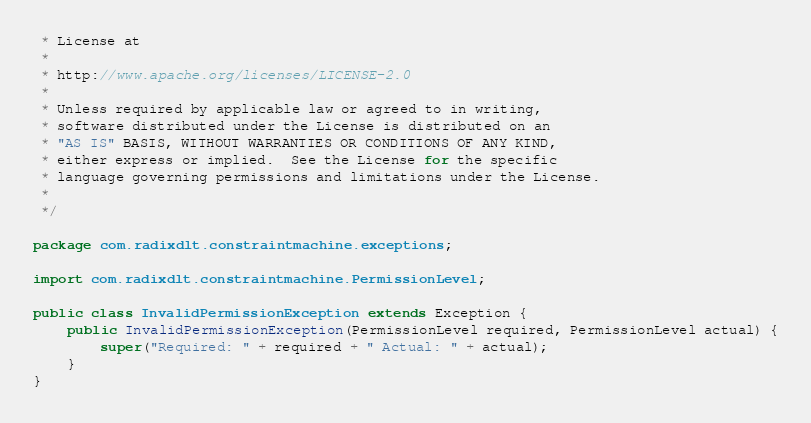Convert code to text. <code><loc_0><loc_0><loc_500><loc_500><_Java_> * License at
 *
 * http://www.apache.org/licenses/LICENSE-2.0
 *
 * Unless required by applicable law or agreed to in writing,
 * software distributed under the License is distributed on an
 * "AS IS" BASIS, WITHOUT WARRANTIES OR CONDITIONS OF ANY KIND,
 * either express or implied.  See the License for the specific
 * language governing permissions and limitations under the License.
 *
 */

package com.radixdlt.constraintmachine.exceptions;

import com.radixdlt.constraintmachine.PermissionLevel;

public class InvalidPermissionException extends Exception {
	public InvalidPermissionException(PermissionLevel required, PermissionLevel actual) {
		super("Required: " + required + " Actual: " + actual);
	}
}
</code> 